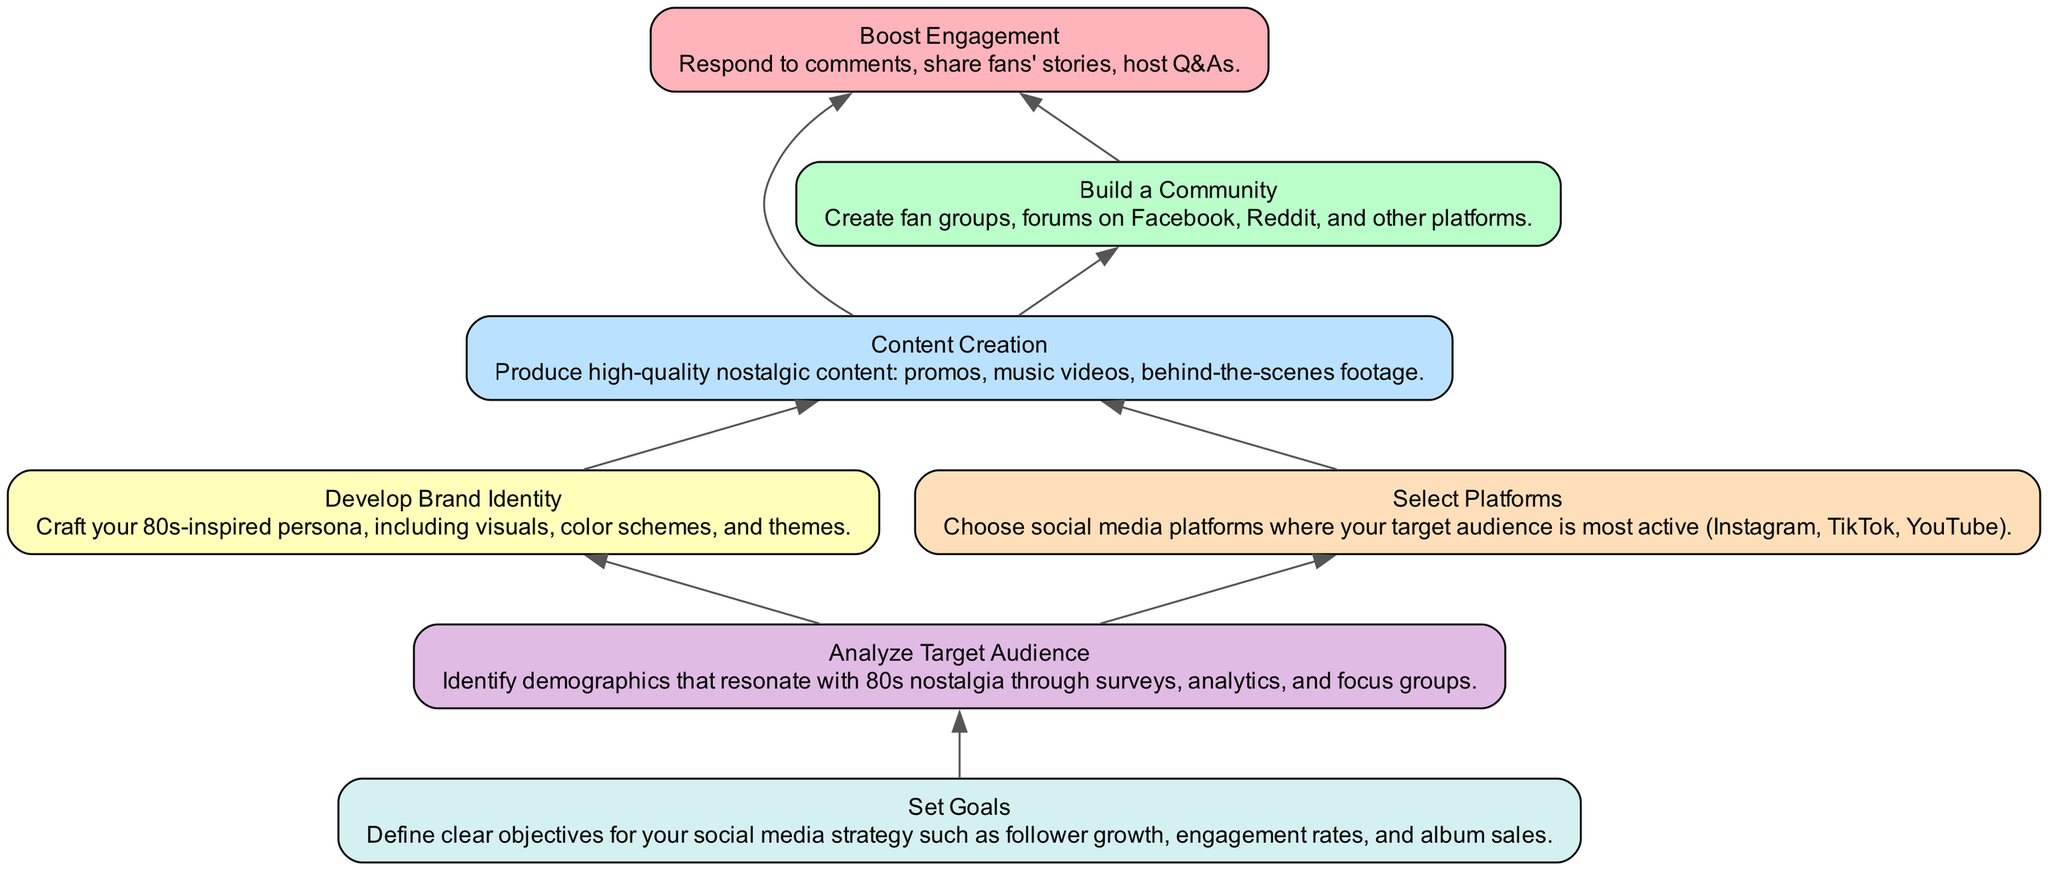What is the topmost element in the diagram? The diagram flows from bottom to top, with "Boost Engagement" being the final step of the strategy and positioned at the top of the diagram.
Answer: Boost Engagement How many total elements are there in this flowchart? Counting all nodes listed in the flowchart, there are seven distinct elements, each representing an important step in building a social media strategy.
Answer: 7 Which elements directly depend on "Content Creation"? "Boost Engagement" and "Build a Community" both identify "Content Creation" as a prerequisite step in the flow of the diagram.
Answer: Boost Engagement, Build a Community What is the main purpose of "Analyze Target Audience"? The purpose of "Analyze Target Audience" is to identify the demographics that resonate with 80s nostalgia, and it serves as a foundational step for setting further strategy goals.
Answer: Identify demographics Which node has the most dependencies? The node "Content Creation" has the highest number of dependent nodes (two dependencies: "Brand Identity" and "Platform Selection"). Thus, it plays a crucial role in the flow of the strategy.
Answer: Content Creation What needs to be done before "Boost Engagement"? Prior to "Boost Engagement," both "Content Creation" and "Build a Community" must be effectively completed, as these steps are prerequisites directly connected to it in the flowchart.
Answer: Content Creation, Build a Community Which element precedes "Content Creation"? The elements that need to be established before "Content Creation" are "Develop Brand Identity" and "Select Platforms," indicating foundational preparations for producing content.
Answer: Develop Brand Identity, Select Platforms 